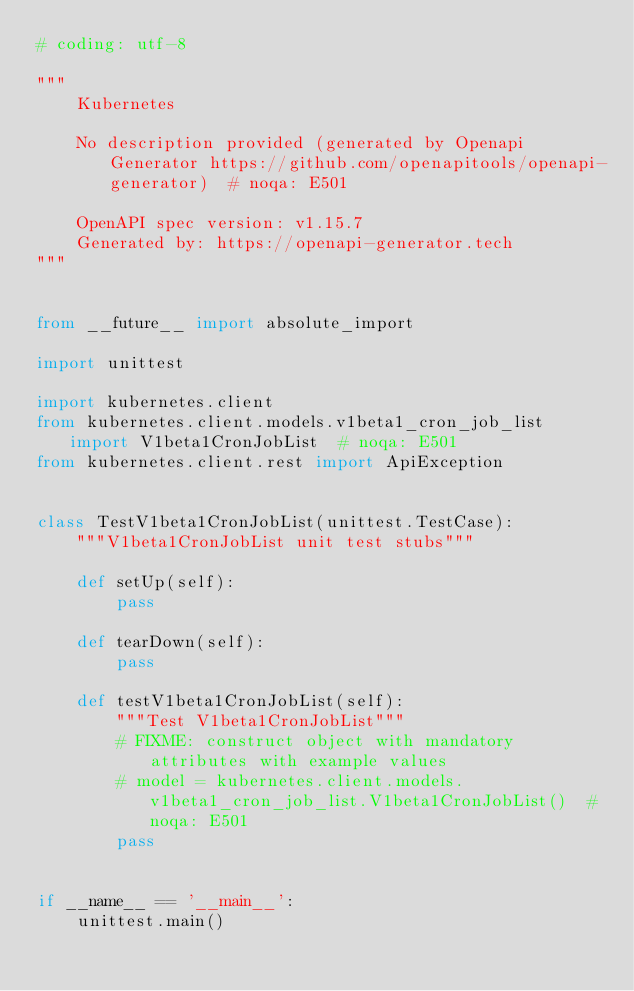<code> <loc_0><loc_0><loc_500><loc_500><_Python_># coding: utf-8

"""
    Kubernetes

    No description provided (generated by Openapi Generator https://github.com/openapitools/openapi-generator)  # noqa: E501

    OpenAPI spec version: v1.15.7
    Generated by: https://openapi-generator.tech
"""


from __future__ import absolute_import

import unittest

import kubernetes.client
from kubernetes.client.models.v1beta1_cron_job_list import V1beta1CronJobList  # noqa: E501
from kubernetes.client.rest import ApiException


class TestV1beta1CronJobList(unittest.TestCase):
    """V1beta1CronJobList unit test stubs"""

    def setUp(self):
        pass

    def tearDown(self):
        pass

    def testV1beta1CronJobList(self):
        """Test V1beta1CronJobList"""
        # FIXME: construct object with mandatory attributes with example values
        # model = kubernetes.client.models.v1beta1_cron_job_list.V1beta1CronJobList()  # noqa: E501
        pass


if __name__ == '__main__':
    unittest.main()
</code> 